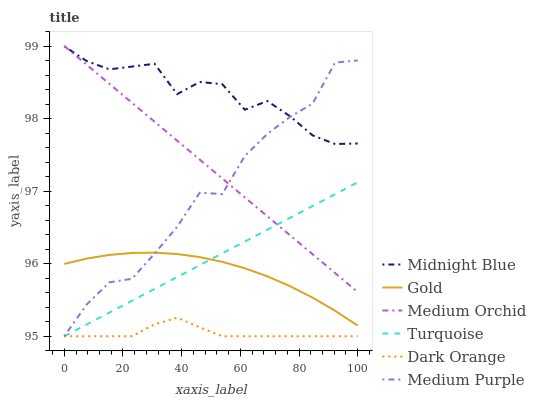Does Dark Orange have the minimum area under the curve?
Answer yes or no. Yes. Does Midnight Blue have the maximum area under the curve?
Answer yes or no. Yes. Does Turquoise have the minimum area under the curve?
Answer yes or no. No. Does Turquoise have the maximum area under the curve?
Answer yes or no. No. Is Turquoise the smoothest?
Answer yes or no. Yes. Is Medium Purple the roughest?
Answer yes or no. Yes. Is Midnight Blue the smoothest?
Answer yes or no. No. Is Midnight Blue the roughest?
Answer yes or no. No. Does Midnight Blue have the lowest value?
Answer yes or no. No. Does Turquoise have the highest value?
Answer yes or no. No. Is Dark Orange less than Gold?
Answer yes or no. Yes. Is Gold greater than Dark Orange?
Answer yes or no. Yes. Does Dark Orange intersect Gold?
Answer yes or no. No. 